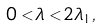Convert formula to latex. <formula><loc_0><loc_0><loc_500><loc_500>0 < \lambda < 2 \lambda _ { 1 } ,</formula> 